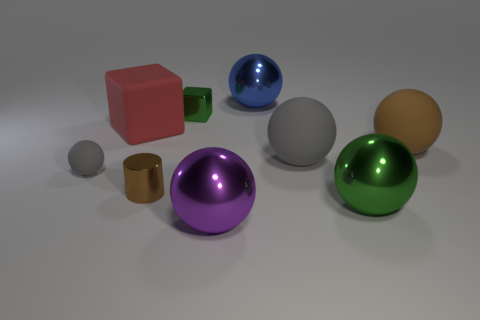Are there any other things that have the same shape as the large brown thing?
Provide a short and direct response. Yes. What number of balls are behind the tiny brown cylinder and on the right side of the brown metallic cylinder?
Ensure brevity in your answer.  3. What is the material of the tiny gray sphere?
Give a very brief answer. Rubber. Is the number of blocks that are in front of the big red matte cube the same as the number of gray metallic blocks?
Make the answer very short. Yes. How many blue objects are the same shape as the small brown shiny object?
Your response must be concise. 0. Is the blue metallic thing the same shape as the small green object?
Offer a terse response. No. What number of things are either gray rubber things that are right of the purple thing or large green spheres?
Your response must be concise. 2. There is a large metal thing that is behind the ball that is on the right side of the green thing in front of the small metal block; what shape is it?
Your answer should be very brief. Sphere. There is a tiny object that is the same material as the green block; what is its shape?
Your answer should be compact. Cylinder. How big is the blue thing?
Offer a terse response. Large. 